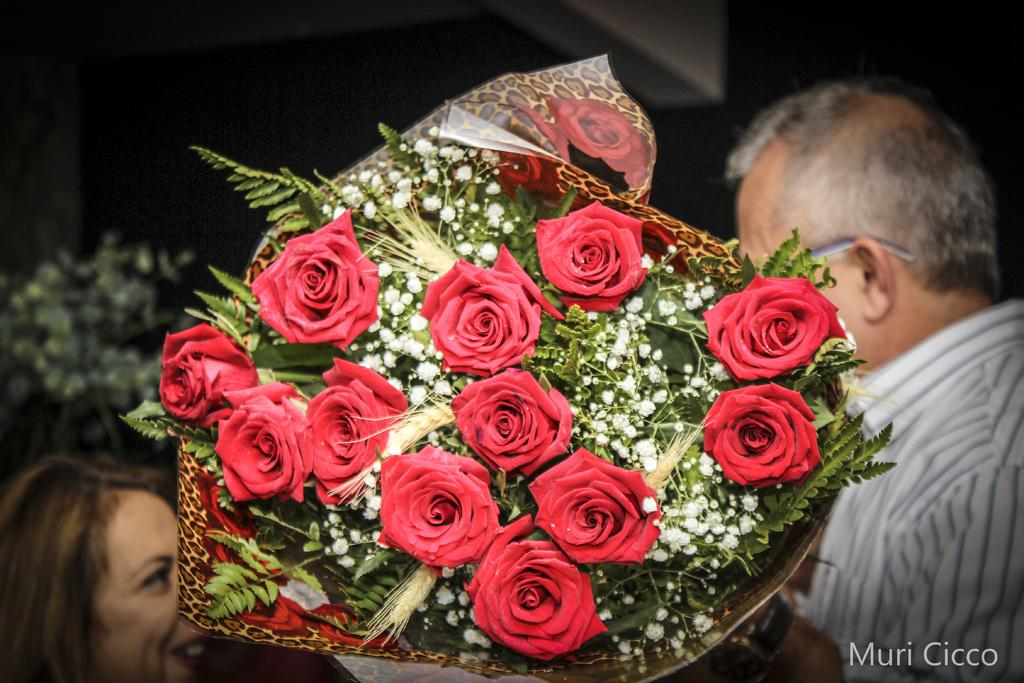Who are the people in the image? There is a man and a woman in the image. What is the man holding in the image? The man is holding a bouquet in the image. What type of flowers are in the bouquet? The bouquet contains rose flowers. How is the woman feeling in the image? The woman is smiling in the image. How many toes can be seen on the woman's foot in the image? There is no visible foot or toes in the image. What is the flock of birds doing in the image? There are no birds present in the image. 